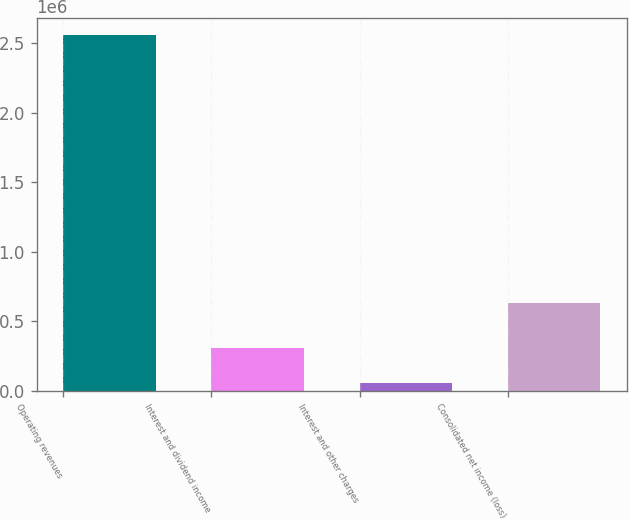Convert chart to OTSL. <chart><loc_0><loc_0><loc_500><loc_500><bar_chart><fcel>Operating revenues<fcel>Interest and dividend income<fcel>Interest and other charges<fcel>Consolidated net income (loss)<nl><fcel>2.55525e+06<fcel>305821<fcel>55884<fcel>631020<nl></chart> 